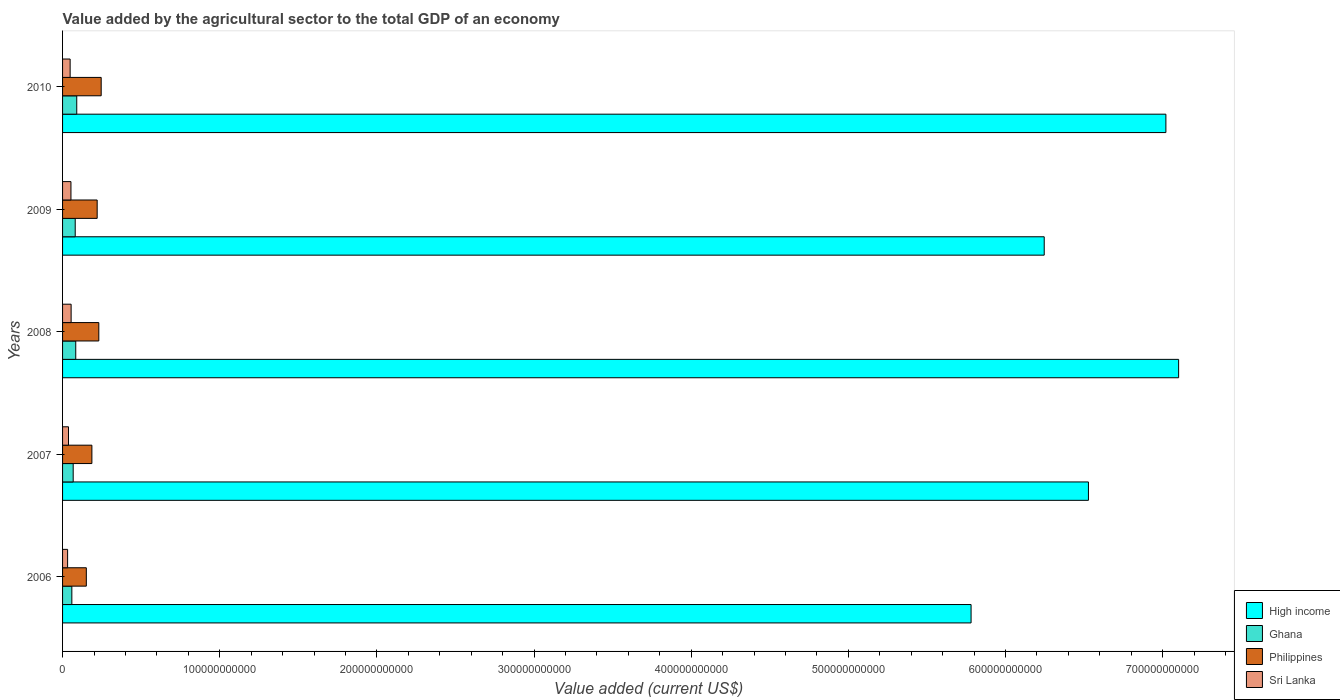How many different coloured bars are there?
Offer a terse response. 4. How many groups of bars are there?
Your response must be concise. 5. Are the number of bars per tick equal to the number of legend labels?
Your answer should be compact. Yes. Are the number of bars on each tick of the Y-axis equal?
Your response must be concise. Yes. How many bars are there on the 1st tick from the top?
Make the answer very short. 4. How many bars are there on the 2nd tick from the bottom?
Provide a succinct answer. 4. What is the label of the 2nd group of bars from the top?
Your answer should be very brief. 2009. What is the value added by the agricultural sector to the total GDP in Sri Lanka in 2007?
Provide a short and direct response. 3.78e+09. Across all years, what is the maximum value added by the agricultural sector to the total GDP in Sri Lanka?
Ensure brevity in your answer.  5.45e+09. Across all years, what is the minimum value added by the agricultural sector to the total GDP in Philippines?
Ensure brevity in your answer.  1.51e+1. What is the total value added by the agricultural sector to the total GDP in Ghana in the graph?
Offer a very short reply. 3.81e+1. What is the difference between the value added by the agricultural sector to the total GDP in Philippines in 2008 and that in 2009?
Give a very brief answer. 1.05e+09. What is the difference between the value added by the agricultural sector to the total GDP in Ghana in 2006 and the value added by the agricultural sector to the total GDP in High income in 2007?
Give a very brief answer. -6.47e+11. What is the average value added by the agricultural sector to the total GDP in Sri Lanka per year?
Keep it short and to the point. 4.52e+09. In the year 2009, what is the difference between the value added by the agricultural sector to the total GDP in Sri Lanka and value added by the agricultural sector to the total GDP in Philippines?
Provide a short and direct response. -1.67e+1. What is the ratio of the value added by the agricultural sector to the total GDP in Sri Lanka in 2007 to that in 2009?
Offer a very short reply. 0.71. Is the difference between the value added by the agricultural sector to the total GDP in Sri Lanka in 2006 and 2008 greater than the difference between the value added by the agricultural sector to the total GDP in Philippines in 2006 and 2008?
Provide a short and direct response. Yes. What is the difference between the highest and the second highest value added by the agricultural sector to the total GDP in Philippines?
Your response must be concise. 1.51e+09. What is the difference between the highest and the lowest value added by the agricultural sector to the total GDP in Ghana?
Make the answer very short. 3.11e+09. Is the sum of the value added by the agricultural sector to the total GDP in Philippines in 2009 and 2010 greater than the maximum value added by the agricultural sector to the total GDP in High income across all years?
Your answer should be compact. No. What does the 4th bar from the bottom in 2007 represents?
Give a very brief answer. Sri Lanka. What is the difference between two consecutive major ticks on the X-axis?
Your answer should be compact. 1.00e+11. Where does the legend appear in the graph?
Ensure brevity in your answer.  Bottom right. How many legend labels are there?
Make the answer very short. 4. How are the legend labels stacked?
Give a very brief answer. Vertical. What is the title of the graph?
Give a very brief answer. Value added by the agricultural sector to the total GDP of an economy. What is the label or title of the X-axis?
Provide a short and direct response. Value added (current US$). What is the label or title of the Y-axis?
Provide a short and direct response. Years. What is the Value added (current US$) of High income in 2006?
Your response must be concise. 5.78e+11. What is the Value added (current US$) in Ghana in 2006?
Your answer should be compact. 5.91e+09. What is the Value added (current US$) of Philippines in 2006?
Give a very brief answer. 1.51e+1. What is the Value added (current US$) of Sri Lanka in 2006?
Your response must be concise. 3.21e+09. What is the Value added (current US$) in High income in 2007?
Your response must be concise. 6.53e+11. What is the Value added (current US$) in Ghana in 2007?
Offer a terse response. 6.76e+09. What is the Value added (current US$) of Philippines in 2007?
Offer a very short reply. 1.87e+1. What is the Value added (current US$) in Sri Lanka in 2007?
Keep it short and to the point. 3.78e+09. What is the Value added (current US$) in High income in 2008?
Offer a very short reply. 7.10e+11. What is the Value added (current US$) of Ghana in 2008?
Your response must be concise. 8.39e+09. What is the Value added (current US$) in Philippines in 2008?
Your answer should be very brief. 2.31e+1. What is the Value added (current US$) in Sri Lanka in 2008?
Provide a short and direct response. 5.45e+09. What is the Value added (current US$) of High income in 2009?
Keep it short and to the point. 6.25e+11. What is the Value added (current US$) in Ghana in 2009?
Offer a terse response. 8.05e+09. What is the Value added (current US$) of Philippines in 2009?
Your answer should be very brief. 2.20e+1. What is the Value added (current US$) in Sri Lanka in 2009?
Your answer should be compact. 5.34e+09. What is the Value added (current US$) in High income in 2010?
Your response must be concise. 7.02e+11. What is the Value added (current US$) of Ghana in 2010?
Provide a succinct answer. 9.02e+09. What is the Value added (current US$) in Philippines in 2010?
Keep it short and to the point. 2.46e+1. What is the Value added (current US$) of Sri Lanka in 2010?
Offer a terse response. 4.82e+09. Across all years, what is the maximum Value added (current US$) in High income?
Your response must be concise. 7.10e+11. Across all years, what is the maximum Value added (current US$) in Ghana?
Offer a terse response. 9.02e+09. Across all years, what is the maximum Value added (current US$) in Philippines?
Offer a terse response. 2.46e+1. Across all years, what is the maximum Value added (current US$) in Sri Lanka?
Your answer should be very brief. 5.45e+09. Across all years, what is the minimum Value added (current US$) of High income?
Offer a terse response. 5.78e+11. Across all years, what is the minimum Value added (current US$) of Ghana?
Give a very brief answer. 5.91e+09. Across all years, what is the minimum Value added (current US$) of Philippines?
Give a very brief answer. 1.51e+1. Across all years, what is the minimum Value added (current US$) in Sri Lanka?
Provide a succinct answer. 3.21e+09. What is the total Value added (current US$) in High income in the graph?
Your response must be concise. 3.27e+12. What is the total Value added (current US$) of Ghana in the graph?
Offer a very short reply. 3.81e+1. What is the total Value added (current US$) of Philippines in the graph?
Your response must be concise. 1.03e+11. What is the total Value added (current US$) in Sri Lanka in the graph?
Ensure brevity in your answer.  2.26e+1. What is the difference between the Value added (current US$) of High income in 2006 and that in 2007?
Offer a terse response. -7.47e+1. What is the difference between the Value added (current US$) in Ghana in 2006 and that in 2007?
Your response must be concise. -8.49e+08. What is the difference between the Value added (current US$) in Philippines in 2006 and that in 2007?
Ensure brevity in your answer.  -3.55e+09. What is the difference between the Value added (current US$) of Sri Lanka in 2006 and that in 2007?
Make the answer very short. -5.74e+08. What is the difference between the Value added (current US$) of High income in 2006 and that in 2008?
Keep it short and to the point. -1.32e+11. What is the difference between the Value added (current US$) in Ghana in 2006 and that in 2008?
Provide a succinct answer. -2.48e+09. What is the difference between the Value added (current US$) in Philippines in 2006 and that in 2008?
Give a very brief answer. -7.95e+09. What is the difference between the Value added (current US$) in Sri Lanka in 2006 and that in 2008?
Offer a very short reply. -2.24e+09. What is the difference between the Value added (current US$) of High income in 2006 and that in 2009?
Provide a short and direct response. -4.65e+1. What is the difference between the Value added (current US$) in Ghana in 2006 and that in 2009?
Provide a short and direct response. -2.14e+09. What is the difference between the Value added (current US$) of Philippines in 2006 and that in 2009?
Provide a short and direct response. -6.90e+09. What is the difference between the Value added (current US$) in Sri Lanka in 2006 and that in 2009?
Make the answer very short. -2.13e+09. What is the difference between the Value added (current US$) in High income in 2006 and that in 2010?
Your answer should be compact. -1.24e+11. What is the difference between the Value added (current US$) in Ghana in 2006 and that in 2010?
Ensure brevity in your answer.  -3.11e+09. What is the difference between the Value added (current US$) of Philippines in 2006 and that in 2010?
Your answer should be very brief. -9.46e+09. What is the difference between the Value added (current US$) in Sri Lanka in 2006 and that in 2010?
Your answer should be compact. -1.61e+09. What is the difference between the Value added (current US$) of High income in 2007 and that in 2008?
Provide a succinct answer. -5.74e+1. What is the difference between the Value added (current US$) in Ghana in 2007 and that in 2008?
Your response must be concise. -1.63e+09. What is the difference between the Value added (current US$) of Philippines in 2007 and that in 2008?
Ensure brevity in your answer.  -4.40e+09. What is the difference between the Value added (current US$) of Sri Lanka in 2007 and that in 2008?
Your answer should be very brief. -1.67e+09. What is the difference between the Value added (current US$) of High income in 2007 and that in 2009?
Make the answer very short. 2.81e+1. What is the difference between the Value added (current US$) of Ghana in 2007 and that in 2009?
Your response must be concise. -1.29e+09. What is the difference between the Value added (current US$) in Philippines in 2007 and that in 2009?
Provide a short and direct response. -3.35e+09. What is the difference between the Value added (current US$) of Sri Lanka in 2007 and that in 2009?
Ensure brevity in your answer.  -1.56e+09. What is the difference between the Value added (current US$) in High income in 2007 and that in 2010?
Keep it short and to the point. -4.93e+1. What is the difference between the Value added (current US$) in Ghana in 2007 and that in 2010?
Offer a very short reply. -2.26e+09. What is the difference between the Value added (current US$) of Philippines in 2007 and that in 2010?
Provide a succinct answer. -5.91e+09. What is the difference between the Value added (current US$) in Sri Lanka in 2007 and that in 2010?
Provide a succinct answer. -1.04e+09. What is the difference between the Value added (current US$) of High income in 2008 and that in 2009?
Offer a terse response. 8.55e+1. What is the difference between the Value added (current US$) of Ghana in 2008 and that in 2009?
Offer a very short reply. 3.38e+08. What is the difference between the Value added (current US$) in Philippines in 2008 and that in 2009?
Provide a short and direct response. 1.05e+09. What is the difference between the Value added (current US$) in Sri Lanka in 2008 and that in 2009?
Offer a very short reply. 1.08e+08. What is the difference between the Value added (current US$) of High income in 2008 and that in 2010?
Your response must be concise. 8.11e+09. What is the difference between the Value added (current US$) of Ghana in 2008 and that in 2010?
Your answer should be compact. -6.32e+08. What is the difference between the Value added (current US$) of Philippines in 2008 and that in 2010?
Keep it short and to the point. -1.51e+09. What is the difference between the Value added (current US$) in Sri Lanka in 2008 and that in 2010?
Keep it short and to the point. 6.28e+08. What is the difference between the Value added (current US$) of High income in 2009 and that in 2010?
Keep it short and to the point. -7.74e+1. What is the difference between the Value added (current US$) in Ghana in 2009 and that in 2010?
Offer a terse response. -9.70e+08. What is the difference between the Value added (current US$) in Philippines in 2009 and that in 2010?
Offer a terse response. -2.56e+09. What is the difference between the Value added (current US$) in Sri Lanka in 2009 and that in 2010?
Offer a very short reply. 5.20e+08. What is the difference between the Value added (current US$) of High income in 2006 and the Value added (current US$) of Ghana in 2007?
Your answer should be compact. 5.71e+11. What is the difference between the Value added (current US$) of High income in 2006 and the Value added (current US$) of Philippines in 2007?
Give a very brief answer. 5.59e+11. What is the difference between the Value added (current US$) in High income in 2006 and the Value added (current US$) in Sri Lanka in 2007?
Provide a short and direct response. 5.74e+11. What is the difference between the Value added (current US$) of Ghana in 2006 and the Value added (current US$) of Philippines in 2007?
Offer a very short reply. -1.28e+1. What is the difference between the Value added (current US$) in Ghana in 2006 and the Value added (current US$) in Sri Lanka in 2007?
Give a very brief answer. 2.13e+09. What is the difference between the Value added (current US$) in Philippines in 2006 and the Value added (current US$) in Sri Lanka in 2007?
Keep it short and to the point. 1.13e+1. What is the difference between the Value added (current US$) in High income in 2006 and the Value added (current US$) in Ghana in 2008?
Your answer should be very brief. 5.70e+11. What is the difference between the Value added (current US$) in High income in 2006 and the Value added (current US$) in Philippines in 2008?
Offer a terse response. 5.55e+11. What is the difference between the Value added (current US$) of High income in 2006 and the Value added (current US$) of Sri Lanka in 2008?
Ensure brevity in your answer.  5.73e+11. What is the difference between the Value added (current US$) in Ghana in 2006 and the Value added (current US$) in Philippines in 2008?
Your response must be concise. -1.72e+1. What is the difference between the Value added (current US$) of Ghana in 2006 and the Value added (current US$) of Sri Lanka in 2008?
Make the answer very short. 4.61e+08. What is the difference between the Value added (current US$) in Philippines in 2006 and the Value added (current US$) in Sri Lanka in 2008?
Make the answer very short. 9.67e+09. What is the difference between the Value added (current US$) in High income in 2006 and the Value added (current US$) in Ghana in 2009?
Your response must be concise. 5.70e+11. What is the difference between the Value added (current US$) in High income in 2006 and the Value added (current US$) in Philippines in 2009?
Your answer should be very brief. 5.56e+11. What is the difference between the Value added (current US$) of High income in 2006 and the Value added (current US$) of Sri Lanka in 2009?
Ensure brevity in your answer.  5.73e+11. What is the difference between the Value added (current US$) of Ghana in 2006 and the Value added (current US$) of Philippines in 2009?
Keep it short and to the point. -1.61e+1. What is the difference between the Value added (current US$) of Ghana in 2006 and the Value added (current US$) of Sri Lanka in 2009?
Provide a short and direct response. 5.69e+08. What is the difference between the Value added (current US$) of Philippines in 2006 and the Value added (current US$) of Sri Lanka in 2009?
Provide a short and direct response. 9.78e+09. What is the difference between the Value added (current US$) in High income in 2006 and the Value added (current US$) in Ghana in 2010?
Provide a succinct answer. 5.69e+11. What is the difference between the Value added (current US$) of High income in 2006 and the Value added (current US$) of Philippines in 2010?
Provide a short and direct response. 5.54e+11. What is the difference between the Value added (current US$) of High income in 2006 and the Value added (current US$) of Sri Lanka in 2010?
Ensure brevity in your answer.  5.73e+11. What is the difference between the Value added (current US$) of Ghana in 2006 and the Value added (current US$) of Philippines in 2010?
Keep it short and to the point. -1.87e+1. What is the difference between the Value added (current US$) of Ghana in 2006 and the Value added (current US$) of Sri Lanka in 2010?
Ensure brevity in your answer.  1.09e+09. What is the difference between the Value added (current US$) in Philippines in 2006 and the Value added (current US$) in Sri Lanka in 2010?
Your answer should be compact. 1.03e+1. What is the difference between the Value added (current US$) of High income in 2007 and the Value added (current US$) of Ghana in 2008?
Your answer should be very brief. 6.44e+11. What is the difference between the Value added (current US$) in High income in 2007 and the Value added (current US$) in Philippines in 2008?
Your answer should be very brief. 6.30e+11. What is the difference between the Value added (current US$) in High income in 2007 and the Value added (current US$) in Sri Lanka in 2008?
Keep it short and to the point. 6.47e+11. What is the difference between the Value added (current US$) of Ghana in 2007 and the Value added (current US$) of Philippines in 2008?
Keep it short and to the point. -1.63e+1. What is the difference between the Value added (current US$) in Ghana in 2007 and the Value added (current US$) in Sri Lanka in 2008?
Your response must be concise. 1.31e+09. What is the difference between the Value added (current US$) of Philippines in 2007 and the Value added (current US$) of Sri Lanka in 2008?
Keep it short and to the point. 1.32e+1. What is the difference between the Value added (current US$) in High income in 2007 and the Value added (current US$) in Ghana in 2009?
Make the answer very short. 6.45e+11. What is the difference between the Value added (current US$) of High income in 2007 and the Value added (current US$) of Philippines in 2009?
Keep it short and to the point. 6.31e+11. What is the difference between the Value added (current US$) in High income in 2007 and the Value added (current US$) in Sri Lanka in 2009?
Keep it short and to the point. 6.47e+11. What is the difference between the Value added (current US$) in Ghana in 2007 and the Value added (current US$) in Philippines in 2009?
Keep it short and to the point. -1.53e+1. What is the difference between the Value added (current US$) in Ghana in 2007 and the Value added (current US$) in Sri Lanka in 2009?
Offer a very short reply. 1.42e+09. What is the difference between the Value added (current US$) in Philippines in 2007 and the Value added (current US$) in Sri Lanka in 2009?
Your answer should be compact. 1.33e+1. What is the difference between the Value added (current US$) in High income in 2007 and the Value added (current US$) in Ghana in 2010?
Keep it short and to the point. 6.44e+11. What is the difference between the Value added (current US$) in High income in 2007 and the Value added (current US$) in Philippines in 2010?
Offer a very short reply. 6.28e+11. What is the difference between the Value added (current US$) of High income in 2007 and the Value added (current US$) of Sri Lanka in 2010?
Offer a very short reply. 6.48e+11. What is the difference between the Value added (current US$) in Ghana in 2007 and the Value added (current US$) in Philippines in 2010?
Make the answer very short. -1.78e+1. What is the difference between the Value added (current US$) of Ghana in 2007 and the Value added (current US$) of Sri Lanka in 2010?
Offer a very short reply. 1.94e+09. What is the difference between the Value added (current US$) in Philippines in 2007 and the Value added (current US$) in Sri Lanka in 2010?
Offer a terse response. 1.38e+1. What is the difference between the Value added (current US$) of High income in 2008 and the Value added (current US$) of Ghana in 2009?
Ensure brevity in your answer.  7.02e+11. What is the difference between the Value added (current US$) of High income in 2008 and the Value added (current US$) of Philippines in 2009?
Keep it short and to the point. 6.88e+11. What is the difference between the Value added (current US$) of High income in 2008 and the Value added (current US$) of Sri Lanka in 2009?
Offer a very short reply. 7.05e+11. What is the difference between the Value added (current US$) of Ghana in 2008 and the Value added (current US$) of Philippines in 2009?
Ensure brevity in your answer.  -1.36e+1. What is the difference between the Value added (current US$) of Ghana in 2008 and the Value added (current US$) of Sri Lanka in 2009?
Provide a short and direct response. 3.05e+09. What is the difference between the Value added (current US$) of Philippines in 2008 and the Value added (current US$) of Sri Lanka in 2009?
Offer a terse response. 1.77e+1. What is the difference between the Value added (current US$) of High income in 2008 and the Value added (current US$) of Ghana in 2010?
Your answer should be compact. 7.01e+11. What is the difference between the Value added (current US$) in High income in 2008 and the Value added (current US$) in Philippines in 2010?
Your response must be concise. 6.86e+11. What is the difference between the Value added (current US$) in High income in 2008 and the Value added (current US$) in Sri Lanka in 2010?
Provide a succinct answer. 7.05e+11. What is the difference between the Value added (current US$) of Ghana in 2008 and the Value added (current US$) of Philippines in 2010?
Provide a short and direct response. -1.62e+1. What is the difference between the Value added (current US$) in Ghana in 2008 and the Value added (current US$) in Sri Lanka in 2010?
Make the answer very short. 3.57e+09. What is the difference between the Value added (current US$) in Philippines in 2008 and the Value added (current US$) in Sri Lanka in 2010?
Your answer should be very brief. 1.82e+1. What is the difference between the Value added (current US$) of High income in 2009 and the Value added (current US$) of Ghana in 2010?
Give a very brief answer. 6.16e+11. What is the difference between the Value added (current US$) in High income in 2009 and the Value added (current US$) in Philippines in 2010?
Your answer should be compact. 6.00e+11. What is the difference between the Value added (current US$) of High income in 2009 and the Value added (current US$) of Sri Lanka in 2010?
Ensure brevity in your answer.  6.20e+11. What is the difference between the Value added (current US$) in Ghana in 2009 and the Value added (current US$) in Philippines in 2010?
Offer a very short reply. -1.65e+1. What is the difference between the Value added (current US$) in Ghana in 2009 and the Value added (current US$) in Sri Lanka in 2010?
Keep it short and to the point. 3.23e+09. What is the difference between the Value added (current US$) of Philippines in 2009 and the Value added (current US$) of Sri Lanka in 2010?
Make the answer very short. 1.72e+1. What is the average Value added (current US$) in High income per year?
Ensure brevity in your answer.  6.54e+11. What is the average Value added (current US$) in Ghana per year?
Provide a succinct answer. 7.63e+09. What is the average Value added (current US$) in Philippines per year?
Your answer should be very brief. 2.07e+1. What is the average Value added (current US$) in Sri Lanka per year?
Offer a terse response. 4.52e+09. In the year 2006, what is the difference between the Value added (current US$) of High income and Value added (current US$) of Ghana?
Keep it short and to the point. 5.72e+11. In the year 2006, what is the difference between the Value added (current US$) of High income and Value added (current US$) of Philippines?
Offer a terse response. 5.63e+11. In the year 2006, what is the difference between the Value added (current US$) of High income and Value added (current US$) of Sri Lanka?
Ensure brevity in your answer.  5.75e+11. In the year 2006, what is the difference between the Value added (current US$) in Ghana and Value added (current US$) in Philippines?
Keep it short and to the point. -9.21e+09. In the year 2006, what is the difference between the Value added (current US$) of Ghana and Value added (current US$) of Sri Lanka?
Offer a terse response. 2.70e+09. In the year 2006, what is the difference between the Value added (current US$) of Philippines and Value added (current US$) of Sri Lanka?
Provide a short and direct response. 1.19e+1. In the year 2007, what is the difference between the Value added (current US$) of High income and Value added (current US$) of Ghana?
Offer a terse response. 6.46e+11. In the year 2007, what is the difference between the Value added (current US$) of High income and Value added (current US$) of Philippines?
Offer a very short reply. 6.34e+11. In the year 2007, what is the difference between the Value added (current US$) of High income and Value added (current US$) of Sri Lanka?
Your response must be concise. 6.49e+11. In the year 2007, what is the difference between the Value added (current US$) of Ghana and Value added (current US$) of Philippines?
Your answer should be very brief. -1.19e+1. In the year 2007, what is the difference between the Value added (current US$) in Ghana and Value added (current US$) in Sri Lanka?
Your answer should be compact. 2.98e+09. In the year 2007, what is the difference between the Value added (current US$) of Philippines and Value added (current US$) of Sri Lanka?
Make the answer very short. 1.49e+1. In the year 2008, what is the difference between the Value added (current US$) in High income and Value added (current US$) in Ghana?
Make the answer very short. 7.02e+11. In the year 2008, what is the difference between the Value added (current US$) of High income and Value added (current US$) of Philippines?
Offer a terse response. 6.87e+11. In the year 2008, what is the difference between the Value added (current US$) in High income and Value added (current US$) in Sri Lanka?
Offer a very short reply. 7.05e+11. In the year 2008, what is the difference between the Value added (current US$) in Ghana and Value added (current US$) in Philippines?
Offer a terse response. -1.47e+1. In the year 2008, what is the difference between the Value added (current US$) of Ghana and Value added (current US$) of Sri Lanka?
Provide a succinct answer. 2.94e+09. In the year 2008, what is the difference between the Value added (current US$) of Philippines and Value added (current US$) of Sri Lanka?
Your response must be concise. 1.76e+1. In the year 2009, what is the difference between the Value added (current US$) of High income and Value added (current US$) of Ghana?
Give a very brief answer. 6.17e+11. In the year 2009, what is the difference between the Value added (current US$) of High income and Value added (current US$) of Philippines?
Provide a succinct answer. 6.03e+11. In the year 2009, what is the difference between the Value added (current US$) of High income and Value added (current US$) of Sri Lanka?
Provide a short and direct response. 6.19e+11. In the year 2009, what is the difference between the Value added (current US$) in Ghana and Value added (current US$) in Philippines?
Provide a short and direct response. -1.40e+1. In the year 2009, what is the difference between the Value added (current US$) in Ghana and Value added (current US$) in Sri Lanka?
Keep it short and to the point. 2.71e+09. In the year 2009, what is the difference between the Value added (current US$) in Philippines and Value added (current US$) in Sri Lanka?
Your response must be concise. 1.67e+1. In the year 2010, what is the difference between the Value added (current US$) of High income and Value added (current US$) of Ghana?
Your answer should be compact. 6.93e+11. In the year 2010, what is the difference between the Value added (current US$) of High income and Value added (current US$) of Philippines?
Your response must be concise. 6.78e+11. In the year 2010, what is the difference between the Value added (current US$) in High income and Value added (current US$) in Sri Lanka?
Give a very brief answer. 6.97e+11. In the year 2010, what is the difference between the Value added (current US$) in Ghana and Value added (current US$) in Philippines?
Your response must be concise. -1.56e+1. In the year 2010, what is the difference between the Value added (current US$) in Ghana and Value added (current US$) in Sri Lanka?
Provide a short and direct response. 4.20e+09. In the year 2010, what is the difference between the Value added (current US$) in Philippines and Value added (current US$) in Sri Lanka?
Offer a terse response. 1.98e+1. What is the ratio of the Value added (current US$) in High income in 2006 to that in 2007?
Your response must be concise. 0.89. What is the ratio of the Value added (current US$) in Ghana in 2006 to that in 2007?
Your answer should be compact. 0.87. What is the ratio of the Value added (current US$) of Philippines in 2006 to that in 2007?
Provide a short and direct response. 0.81. What is the ratio of the Value added (current US$) of Sri Lanka in 2006 to that in 2007?
Offer a terse response. 0.85. What is the ratio of the Value added (current US$) in High income in 2006 to that in 2008?
Offer a terse response. 0.81. What is the ratio of the Value added (current US$) of Ghana in 2006 to that in 2008?
Your answer should be very brief. 0.7. What is the ratio of the Value added (current US$) in Philippines in 2006 to that in 2008?
Keep it short and to the point. 0.66. What is the ratio of the Value added (current US$) of Sri Lanka in 2006 to that in 2008?
Provide a short and direct response. 0.59. What is the ratio of the Value added (current US$) of High income in 2006 to that in 2009?
Offer a terse response. 0.93. What is the ratio of the Value added (current US$) in Ghana in 2006 to that in 2009?
Your answer should be very brief. 0.73. What is the ratio of the Value added (current US$) of Philippines in 2006 to that in 2009?
Offer a very short reply. 0.69. What is the ratio of the Value added (current US$) of Sri Lanka in 2006 to that in 2009?
Make the answer very short. 0.6. What is the ratio of the Value added (current US$) of High income in 2006 to that in 2010?
Give a very brief answer. 0.82. What is the ratio of the Value added (current US$) in Ghana in 2006 to that in 2010?
Offer a very short reply. 0.65. What is the ratio of the Value added (current US$) in Philippines in 2006 to that in 2010?
Make the answer very short. 0.61. What is the ratio of the Value added (current US$) of Sri Lanka in 2006 to that in 2010?
Your response must be concise. 0.67. What is the ratio of the Value added (current US$) of High income in 2007 to that in 2008?
Keep it short and to the point. 0.92. What is the ratio of the Value added (current US$) of Ghana in 2007 to that in 2008?
Provide a succinct answer. 0.81. What is the ratio of the Value added (current US$) in Philippines in 2007 to that in 2008?
Your response must be concise. 0.81. What is the ratio of the Value added (current US$) in Sri Lanka in 2007 to that in 2008?
Offer a terse response. 0.69. What is the ratio of the Value added (current US$) in High income in 2007 to that in 2009?
Your answer should be compact. 1.04. What is the ratio of the Value added (current US$) in Ghana in 2007 to that in 2009?
Offer a terse response. 0.84. What is the ratio of the Value added (current US$) of Philippines in 2007 to that in 2009?
Your answer should be very brief. 0.85. What is the ratio of the Value added (current US$) of Sri Lanka in 2007 to that in 2009?
Make the answer very short. 0.71. What is the ratio of the Value added (current US$) of High income in 2007 to that in 2010?
Give a very brief answer. 0.93. What is the ratio of the Value added (current US$) in Ghana in 2007 to that in 2010?
Provide a succinct answer. 0.75. What is the ratio of the Value added (current US$) of Philippines in 2007 to that in 2010?
Your answer should be compact. 0.76. What is the ratio of the Value added (current US$) in Sri Lanka in 2007 to that in 2010?
Ensure brevity in your answer.  0.78. What is the ratio of the Value added (current US$) in High income in 2008 to that in 2009?
Provide a succinct answer. 1.14. What is the ratio of the Value added (current US$) in Ghana in 2008 to that in 2009?
Provide a short and direct response. 1.04. What is the ratio of the Value added (current US$) of Philippines in 2008 to that in 2009?
Offer a very short reply. 1.05. What is the ratio of the Value added (current US$) of Sri Lanka in 2008 to that in 2009?
Offer a very short reply. 1.02. What is the ratio of the Value added (current US$) in High income in 2008 to that in 2010?
Ensure brevity in your answer.  1.01. What is the ratio of the Value added (current US$) in Ghana in 2008 to that in 2010?
Your answer should be very brief. 0.93. What is the ratio of the Value added (current US$) of Philippines in 2008 to that in 2010?
Your answer should be very brief. 0.94. What is the ratio of the Value added (current US$) of Sri Lanka in 2008 to that in 2010?
Your response must be concise. 1.13. What is the ratio of the Value added (current US$) of High income in 2009 to that in 2010?
Ensure brevity in your answer.  0.89. What is the ratio of the Value added (current US$) of Ghana in 2009 to that in 2010?
Offer a very short reply. 0.89. What is the ratio of the Value added (current US$) in Philippines in 2009 to that in 2010?
Provide a short and direct response. 0.9. What is the ratio of the Value added (current US$) in Sri Lanka in 2009 to that in 2010?
Keep it short and to the point. 1.11. What is the difference between the highest and the second highest Value added (current US$) in High income?
Make the answer very short. 8.11e+09. What is the difference between the highest and the second highest Value added (current US$) of Ghana?
Keep it short and to the point. 6.32e+08. What is the difference between the highest and the second highest Value added (current US$) of Philippines?
Give a very brief answer. 1.51e+09. What is the difference between the highest and the second highest Value added (current US$) of Sri Lanka?
Keep it short and to the point. 1.08e+08. What is the difference between the highest and the lowest Value added (current US$) of High income?
Ensure brevity in your answer.  1.32e+11. What is the difference between the highest and the lowest Value added (current US$) of Ghana?
Provide a short and direct response. 3.11e+09. What is the difference between the highest and the lowest Value added (current US$) of Philippines?
Offer a terse response. 9.46e+09. What is the difference between the highest and the lowest Value added (current US$) in Sri Lanka?
Give a very brief answer. 2.24e+09. 